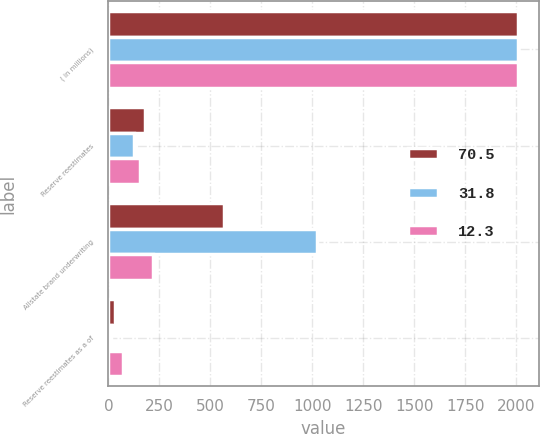<chart> <loc_0><loc_0><loc_500><loc_500><stacked_bar_chart><ecel><fcel>( in millions)<fcel>Reserve reestimates<fcel>Allstate brand underwriting<fcel>Reserve reestimates as a of<nl><fcel>70.5<fcel>2010<fcel>181<fcel>569<fcel>31.8<nl><fcel>31.8<fcel>2009<fcel>126<fcel>1022<fcel>12.3<nl><fcel>12.3<fcel>2008<fcel>155<fcel>220<fcel>70.5<nl></chart> 